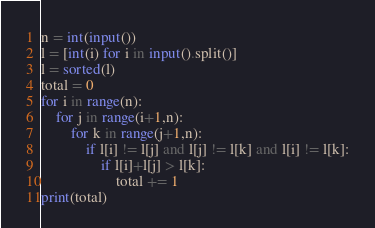<code> <loc_0><loc_0><loc_500><loc_500><_Python_>n = int(input())
l = [int(i) for i in input().split()]
l = sorted(l)
total = 0
for i in range(n):
    for j in range(i+1,n):
        for k in range(j+1,n):
            if l[i] != l[j] and l[j] != l[k] and l[i] != l[k]:
                if l[i]+l[j] > l[k]:
                    total += 1
print(total)</code> 